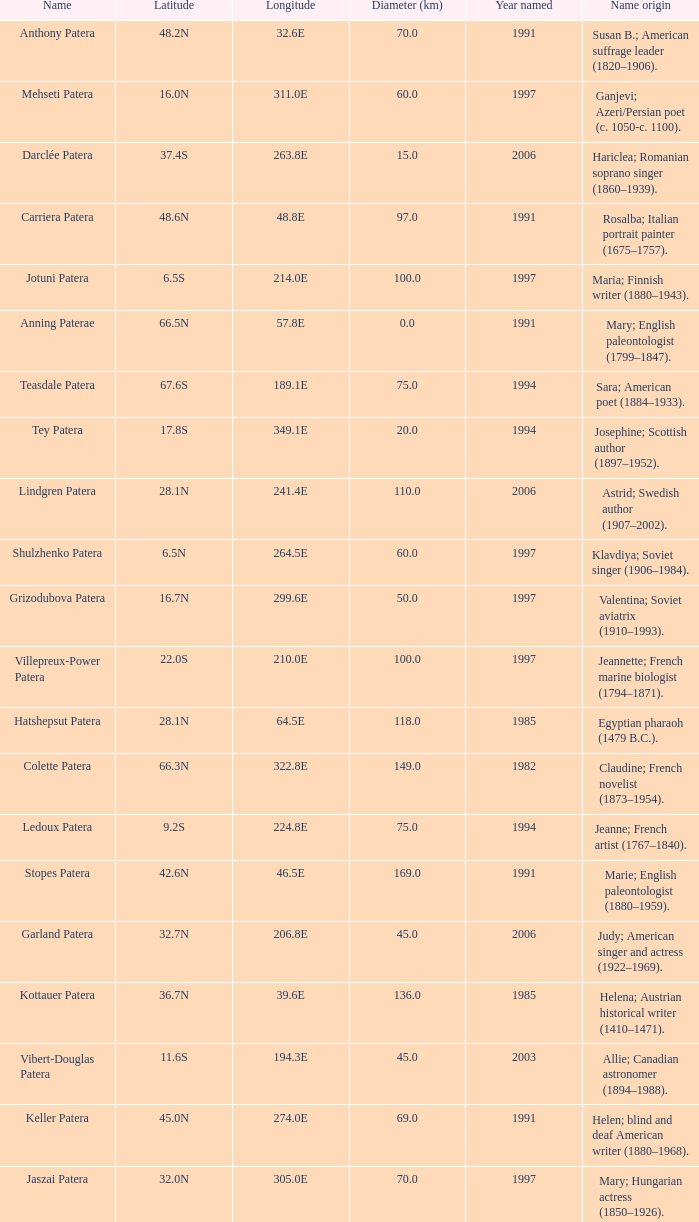What is  the diameter in km of the feature with a longitude of 40.2E?  135.0. 